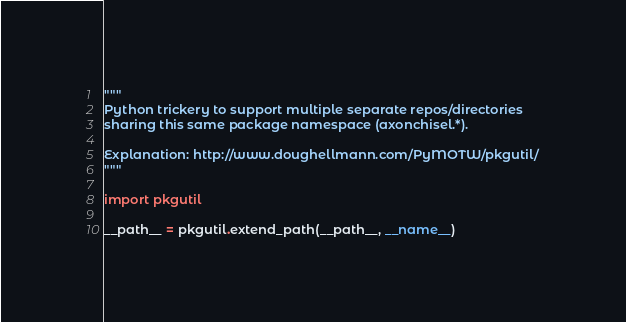<code> <loc_0><loc_0><loc_500><loc_500><_Python_>"""
Python trickery to support multiple separate repos/directories
sharing this same package namespace (axonchisel.*).

Explanation: http://www.doughellmann.com/PyMOTW/pkgutil/
"""

import pkgutil

__path__ = pkgutil.extend_path(__path__, __name__)
</code> 